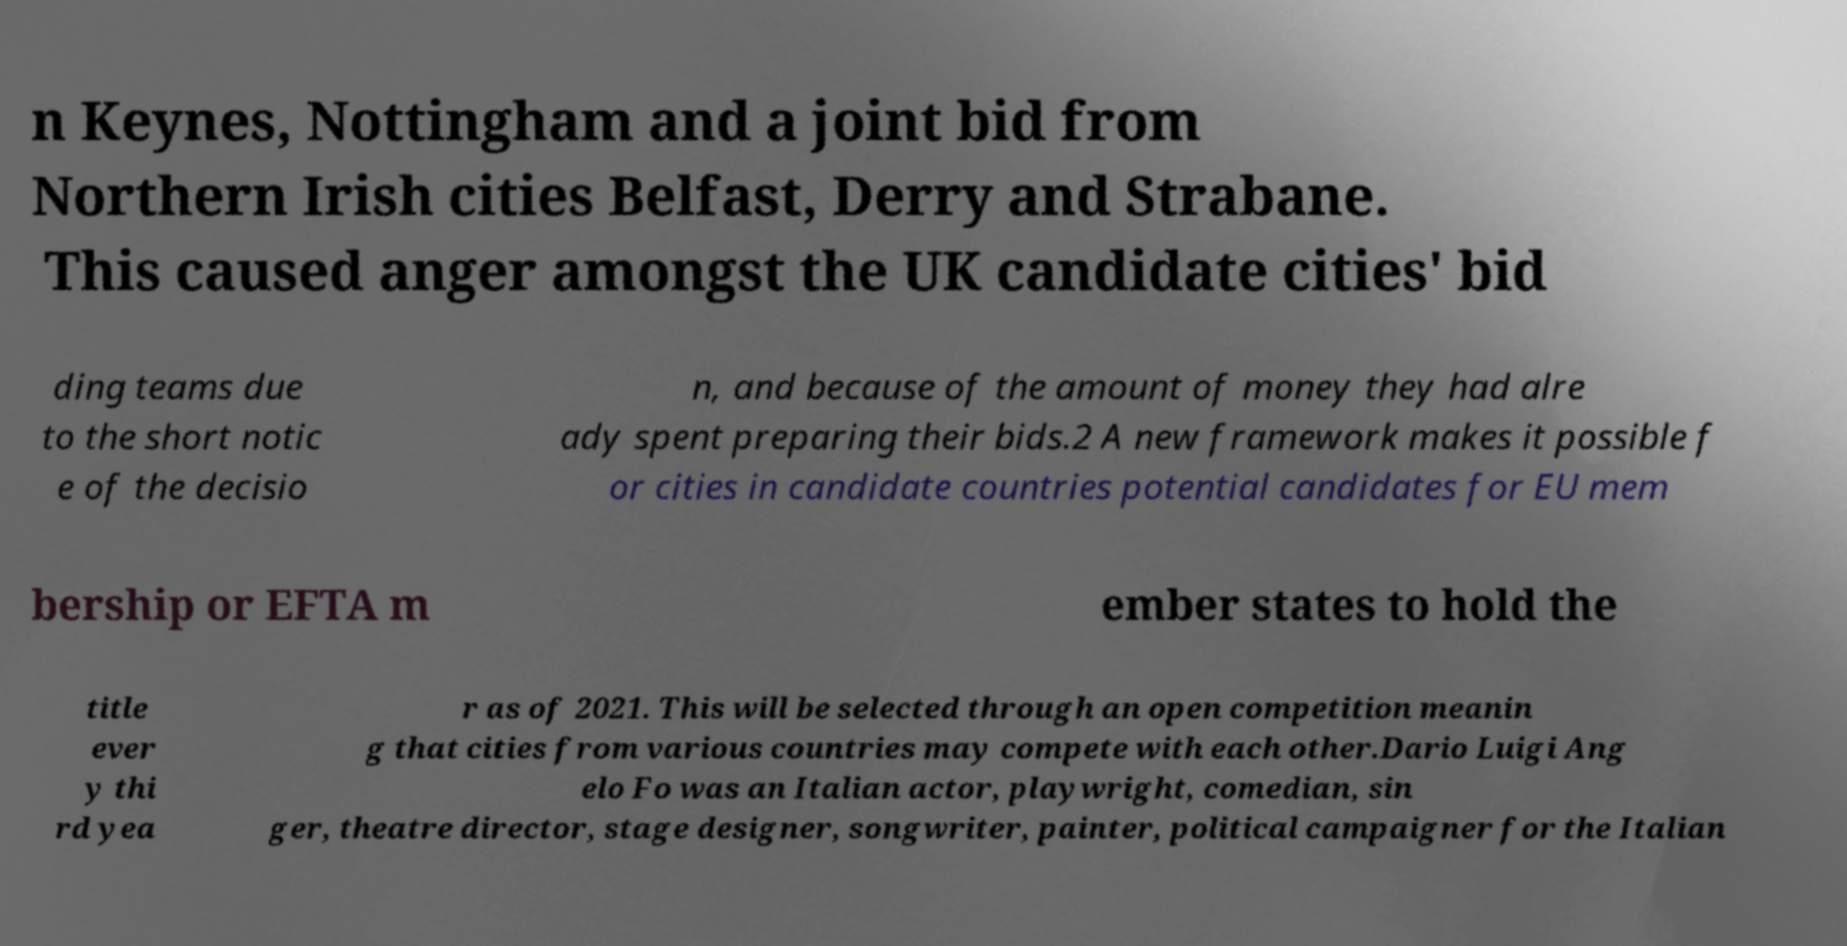For documentation purposes, I need the text within this image transcribed. Could you provide that? n Keynes, Nottingham and a joint bid from Northern Irish cities Belfast, Derry and Strabane. This caused anger amongst the UK candidate cities' bid ding teams due to the short notic e of the decisio n, and because of the amount of money they had alre ady spent preparing their bids.2 A new framework makes it possible f or cities in candidate countries potential candidates for EU mem bership or EFTA m ember states to hold the title ever y thi rd yea r as of 2021. This will be selected through an open competition meanin g that cities from various countries may compete with each other.Dario Luigi Ang elo Fo was an Italian actor, playwright, comedian, sin ger, theatre director, stage designer, songwriter, painter, political campaigner for the Italian 